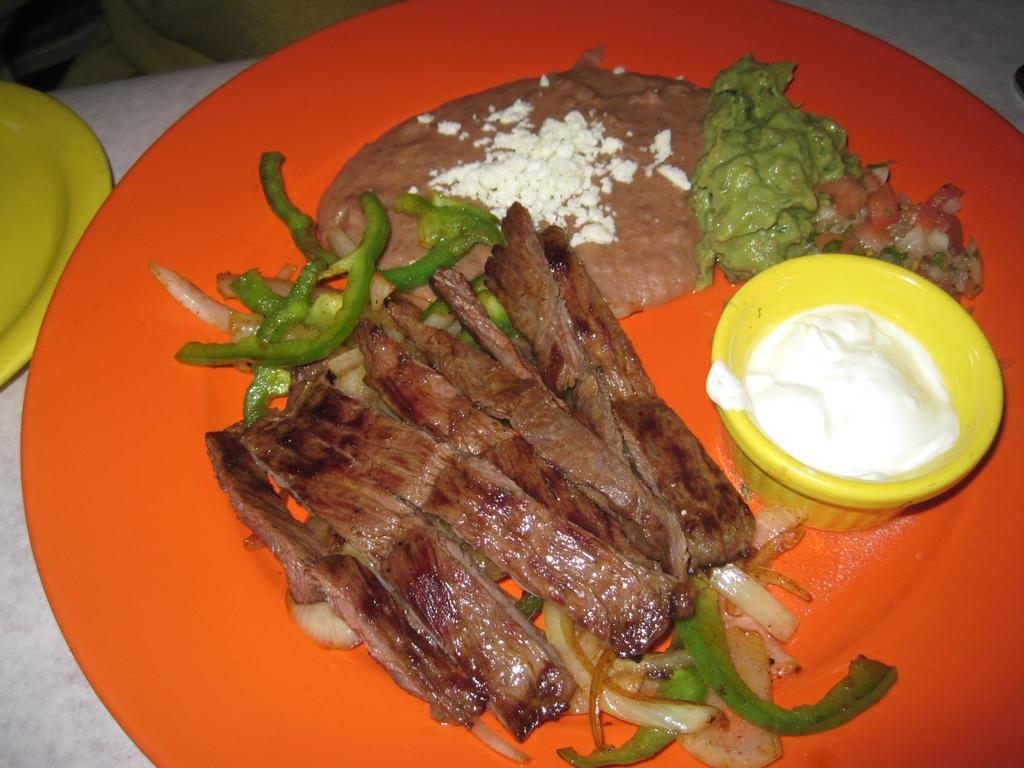What is located in the foreground of the image? There is food and a cream in a bowl in the foreground of the image. What is the cream in the bowl placed on? The cream in a bowl is placed on an orange platter. What is the surface beneath the platter? The platter is on a stone surface. Are there any other platters visible in the image? Yes, there is another platter on the left side of the image. What type of grain is being processed at the airport in the image? There is no airport or grain present in the image; it features food and cream in a bowl on a platter. 